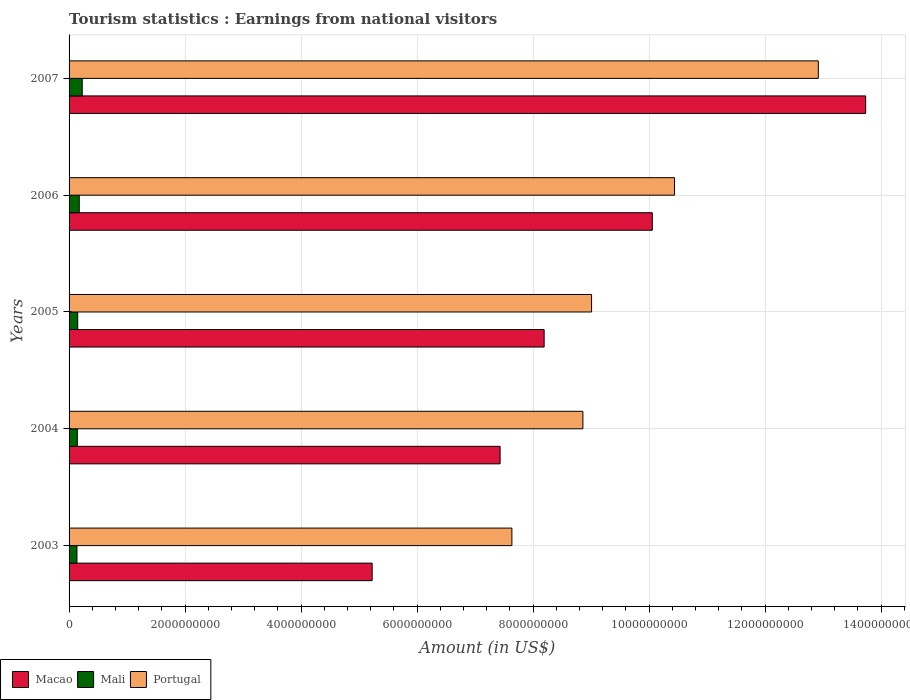Are the number of bars per tick equal to the number of legend labels?
Your answer should be compact. Yes. Are the number of bars on each tick of the Y-axis equal?
Give a very brief answer. Yes. How many bars are there on the 3rd tick from the bottom?
Give a very brief answer. 3. What is the label of the 3rd group of bars from the top?
Make the answer very short. 2005. In how many cases, is the number of bars for a given year not equal to the number of legend labels?
Make the answer very short. 0. What is the earnings from national visitors in Macao in 2003?
Give a very brief answer. 5.22e+09. Across all years, what is the maximum earnings from national visitors in Mali?
Your response must be concise. 2.27e+08. Across all years, what is the minimum earnings from national visitors in Mali?
Keep it short and to the point. 1.36e+08. What is the total earnings from national visitors in Portugal in the graph?
Offer a terse response. 4.89e+1. What is the difference between the earnings from national visitors in Macao in 2004 and that in 2007?
Offer a terse response. -6.30e+09. What is the difference between the earnings from national visitors in Mali in 2004 and the earnings from national visitors in Portugal in 2003?
Your answer should be compact. -7.49e+09. What is the average earnings from national visitors in Mali per year?
Offer a terse response. 1.66e+08. In the year 2004, what is the difference between the earnings from national visitors in Portugal and earnings from national visitors in Mali?
Ensure brevity in your answer.  8.72e+09. In how many years, is the earnings from national visitors in Portugal greater than 6000000000 US$?
Your response must be concise. 5. What is the ratio of the earnings from national visitors in Portugal in 2004 to that in 2005?
Make the answer very short. 0.98. What is the difference between the highest and the second highest earnings from national visitors in Mali?
Give a very brief answer. 5.16e+07. What is the difference between the highest and the lowest earnings from national visitors in Portugal?
Your answer should be compact. 5.28e+09. In how many years, is the earnings from national visitors in Portugal greater than the average earnings from national visitors in Portugal taken over all years?
Offer a terse response. 2. What does the 2nd bar from the top in 2004 represents?
Ensure brevity in your answer.  Mali. What does the 1st bar from the bottom in 2003 represents?
Make the answer very short. Macao. Is it the case that in every year, the sum of the earnings from national visitors in Macao and earnings from national visitors in Mali is greater than the earnings from national visitors in Portugal?
Provide a succinct answer. No. Are all the bars in the graph horizontal?
Your response must be concise. Yes. How many years are there in the graph?
Keep it short and to the point. 5. Are the values on the major ticks of X-axis written in scientific E-notation?
Offer a very short reply. No. Does the graph contain grids?
Offer a terse response. Yes. How many legend labels are there?
Keep it short and to the point. 3. How are the legend labels stacked?
Provide a succinct answer. Horizontal. What is the title of the graph?
Your answer should be compact. Tourism statistics : Earnings from national visitors. Does "Nicaragua" appear as one of the legend labels in the graph?
Offer a very short reply. No. What is the label or title of the Y-axis?
Ensure brevity in your answer.  Years. What is the Amount (in US$) of Macao in 2003?
Offer a terse response. 5.22e+09. What is the Amount (in US$) in Mali in 2003?
Provide a short and direct response. 1.36e+08. What is the Amount (in US$) of Portugal in 2003?
Offer a very short reply. 7.63e+09. What is the Amount (in US$) of Macao in 2004?
Offer a very short reply. 7.43e+09. What is the Amount (in US$) of Mali in 2004?
Give a very brief answer. 1.42e+08. What is the Amount (in US$) in Portugal in 2004?
Give a very brief answer. 8.86e+09. What is the Amount (in US$) of Macao in 2005?
Keep it short and to the point. 8.19e+09. What is the Amount (in US$) of Mali in 2005?
Your answer should be compact. 1.49e+08. What is the Amount (in US$) in Portugal in 2005?
Your response must be concise. 9.01e+09. What is the Amount (in US$) of Macao in 2006?
Your answer should be very brief. 1.01e+1. What is the Amount (in US$) in Mali in 2006?
Ensure brevity in your answer.  1.75e+08. What is the Amount (in US$) in Portugal in 2006?
Provide a succinct answer. 1.04e+1. What is the Amount (in US$) in Macao in 2007?
Give a very brief answer. 1.37e+1. What is the Amount (in US$) of Mali in 2007?
Offer a very short reply. 2.27e+08. What is the Amount (in US$) in Portugal in 2007?
Ensure brevity in your answer.  1.29e+1. Across all years, what is the maximum Amount (in US$) in Macao?
Offer a terse response. 1.37e+1. Across all years, what is the maximum Amount (in US$) in Mali?
Offer a very short reply. 2.27e+08. Across all years, what is the maximum Amount (in US$) of Portugal?
Provide a short and direct response. 1.29e+1. Across all years, what is the minimum Amount (in US$) of Macao?
Provide a short and direct response. 5.22e+09. Across all years, what is the minimum Amount (in US$) in Mali?
Your response must be concise. 1.36e+08. Across all years, what is the minimum Amount (in US$) of Portugal?
Give a very brief answer. 7.63e+09. What is the total Amount (in US$) of Macao in the graph?
Make the answer very short. 4.46e+1. What is the total Amount (in US$) in Mali in the graph?
Keep it short and to the point. 8.30e+08. What is the total Amount (in US$) of Portugal in the graph?
Keep it short and to the point. 4.89e+1. What is the difference between the Amount (in US$) of Macao in 2003 and that in 2004?
Your response must be concise. -2.21e+09. What is the difference between the Amount (in US$) in Mali in 2003 and that in 2004?
Your answer should be very brief. -6.30e+06. What is the difference between the Amount (in US$) in Portugal in 2003 and that in 2004?
Provide a short and direct response. -1.22e+09. What is the difference between the Amount (in US$) in Macao in 2003 and that in 2005?
Provide a succinct answer. -2.96e+09. What is the difference between the Amount (in US$) in Mali in 2003 and that in 2005?
Give a very brief answer. -1.32e+07. What is the difference between the Amount (in US$) in Portugal in 2003 and that in 2005?
Provide a short and direct response. -1.37e+09. What is the difference between the Amount (in US$) of Macao in 2003 and that in 2006?
Your answer should be very brief. -4.83e+09. What is the difference between the Amount (in US$) in Mali in 2003 and that in 2006?
Provide a short and direct response. -3.94e+07. What is the difference between the Amount (in US$) in Portugal in 2003 and that in 2006?
Your answer should be very brief. -2.80e+09. What is the difference between the Amount (in US$) in Macao in 2003 and that in 2007?
Offer a very short reply. -8.51e+09. What is the difference between the Amount (in US$) in Mali in 2003 and that in 2007?
Your response must be concise. -9.10e+07. What is the difference between the Amount (in US$) in Portugal in 2003 and that in 2007?
Provide a succinct answer. -5.28e+09. What is the difference between the Amount (in US$) of Macao in 2004 and that in 2005?
Make the answer very short. -7.59e+08. What is the difference between the Amount (in US$) of Mali in 2004 and that in 2005?
Keep it short and to the point. -6.90e+06. What is the difference between the Amount (in US$) in Portugal in 2004 and that in 2005?
Offer a very short reply. -1.50e+08. What is the difference between the Amount (in US$) of Macao in 2004 and that in 2006?
Provide a short and direct response. -2.62e+09. What is the difference between the Amount (in US$) in Mali in 2004 and that in 2006?
Give a very brief answer. -3.31e+07. What is the difference between the Amount (in US$) of Portugal in 2004 and that in 2006?
Offer a very short reply. -1.58e+09. What is the difference between the Amount (in US$) in Macao in 2004 and that in 2007?
Offer a very short reply. -6.30e+09. What is the difference between the Amount (in US$) in Mali in 2004 and that in 2007?
Your answer should be very brief. -8.47e+07. What is the difference between the Amount (in US$) in Portugal in 2004 and that in 2007?
Your answer should be compact. -4.06e+09. What is the difference between the Amount (in US$) in Macao in 2005 and that in 2006?
Your answer should be very brief. -1.86e+09. What is the difference between the Amount (in US$) in Mali in 2005 and that in 2006?
Your answer should be very brief. -2.62e+07. What is the difference between the Amount (in US$) in Portugal in 2005 and that in 2006?
Provide a succinct answer. -1.43e+09. What is the difference between the Amount (in US$) of Macao in 2005 and that in 2007?
Give a very brief answer. -5.54e+09. What is the difference between the Amount (in US$) in Mali in 2005 and that in 2007?
Offer a terse response. -7.78e+07. What is the difference between the Amount (in US$) of Portugal in 2005 and that in 2007?
Provide a succinct answer. -3.91e+09. What is the difference between the Amount (in US$) of Macao in 2006 and that in 2007?
Ensure brevity in your answer.  -3.68e+09. What is the difference between the Amount (in US$) in Mali in 2006 and that in 2007?
Keep it short and to the point. -5.16e+07. What is the difference between the Amount (in US$) in Portugal in 2006 and that in 2007?
Give a very brief answer. -2.48e+09. What is the difference between the Amount (in US$) in Macao in 2003 and the Amount (in US$) in Mali in 2004?
Offer a terse response. 5.08e+09. What is the difference between the Amount (in US$) in Macao in 2003 and the Amount (in US$) in Portugal in 2004?
Your response must be concise. -3.63e+09. What is the difference between the Amount (in US$) of Mali in 2003 and the Amount (in US$) of Portugal in 2004?
Make the answer very short. -8.72e+09. What is the difference between the Amount (in US$) in Macao in 2003 and the Amount (in US$) in Mali in 2005?
Provide a succinct answer. 5.08e+09. What is the difference between the Amount (in US$) in Macao in 2003 and the Amount (in US$) in Portugal in 2005?
Give a very brief answer. -3.78e+09. What is the difference between the Amount (in US$) in Mali in 2003 and the Amount (in US$) in Portugal in 2005?
Ensure brevity in your answer.  -8.87e+09. What is the difference between the Amount (in US$) of Macao in 2003 and the Amount (in US$) of Mali in 2006?
Provide a succinct answer. 5.05e+09. What is the difference between the Amount (in US$) of Macao in 2003 and the Amount (in US$) of Portugal in 2006?
Offer a very short reply. -5.21e+09. What is the difference between the Amount (in US$) in Mali in 2003 and the Amount (in US$) in Portugal in 2006?
Provide a succinct answer. -1.03e+1. What is the difference between the Amount (in US$) of Macao in 2003 and the Amount (in US$) of Mali in 2007?
Offer a terse response. 5.00e+09. What is the difference between the Amount (in US$) in Macao in 2003 and the Amount (in US$) in Portugal in 2007?
Make the answer very short. -7.69e+09. What is the difference between the Amount (in US$) in Mali in 2003 and the Amount (in US$) in Portugal in 2007?
Keep it short and to the point. -1.28e+1. What is the difference between the Amount (in US$) in Macao in 2004 and the Amount (in US$) in Mali in 2005?
Your response must be concise. 7.28e+09. What is the difference between the Amount (in US$) in Macao in 2004 and the Amount (in US$) in Portugal in 2005?
Provide a succinct answer. -1.58e+09. What is the difference between the Amount (in US$) of Mali in 2004 and the Amount (in US$) of Portugal in 2005?
Keep it short and to the point. -8.87e+09. What is the difference between the Amount (in US$) of Macao in 2004 and the Amount (in US$) of Mali in 2006?
Provide a short and direct response. 7.26e+09. What is the difference between the Amount (in US$) of Macao in 2004 and the Amount (in US$) of Portugal in 2006?
Keep it short and to the point. -3.01e+09. What is the difference between the Amount (in US$) of Mali in 2004 and the Amount (in US$) of Portugal in 2006?
Provide a short and direct response. -1.03e+1. What is the difference between the Amount (in US$) of Macao in 2004 and the Amount (in US$) of Mali in 2007?
Provide a succinct answer. 7.20e+09. What is the difference between the Amount (in US$) in Macao in 2004 and the Amount (in US$) in Portugal in 2007?
Your answer should be compact. -5.49e+09. What is the difference between the Amount (in US$) of Mali in 2004 and the Amount (in US$) of Portugal in 2007?
Keep it short and to the point. -1.28e+1. What is the difference between the Amount (in US$) in Macao in 2005 and the Amount (in US$) in Mali in 2006?
Your response must be concise. 8.01e+09. What is the difference between the Amount (in US$) of Macao in 2005 and the Amount (in US$) of Portugal in 2006?
Offer a very short reply. -2.25e+09. What is the difference between the Amount (in US$) of Mali in 2005 and the Amount (in US$) of Portugal in 2006?
Your answer should be compact. -1.03e+1. What is the difference between the Amount (in US$) in Macao in 2005 and the Amount (in US$) in Mali in 2007?
Provide a short and direct response. 7.96e+09. What is the difference between the Amount (in US$) in Macao in 2005 and the Amount (in US$) in Portugal in 2007?
Keep it short and to the point. -4.73e+09. What is the difference between the Amount (in US$) of Mali in 2005 and the Amount (in US$) of Portugal in 2007?
Your response must be concise. -1.28e+1. What is the difference between the Amount (in US$) of Macao in 2006 and the Amount (in US$) of Mali in 2007?
Keep it short and to the point. 9.83e+09. What is the difference between the Amount (in US$) of Macao in 2006 and the Amount (in US$) of Portugal in 2007?
Keep it short and to the point. -2.86e+09. What is the difference between the Amount (in US$) in Mali in 2006 and the Amount (in US$) in Portugal in 2007?
Keep it short and to the point. -1.27e+1. What is the average Amount (in US$) of Macao per year?
Your response must be concise. 8.93e+09. What is the average Amount (in US$) of Mali per year?
Provide a short and direct response. 1.66e+08. What is the average Amount (in US$) of Portugal per year?
Make the answer very short. 9.77e+09. In the year 2003, what is the difference between the Amount (in US$) of Macao and Amount (in US$) of Mali?
Provide a short and direct response. 5.09e+09. In the year 2003, what is the difference between the Amount (in US$) in Macao and Amount (in US$) in Portugal?
Make the answer very short. -2.41e+09. In the year 2003, what is the difference between the Amount (in US$) in Mali and Amount (in US$) in Portugal?
Give a very brief answer. -7.50e+09. In the year 2004, what is the difference between the Amount (in US$) of Macao and Amount (in US$) of Mali?
Your response must be concise. 7.29e+09. In the year 2004, what is the difference between the Amount (in US$) in Macao and Amount (in US$) in Portugal?
Offer a very short reply. -1.43e+09. In the year 2004, what is the difference between the Amount (in US$) in Mali and Amount (in US$) in Portugal?
Your answer should be compact. -8.72e+09. In the year 2005, what is the difference between the Amount (in US$) in Macao and Amount (in US$) in Mali?
Your answer should be very brief. 8.04e+09. In the year 2005, what is the difference between the Amount (in US$) of Macao and Amount (in US$) of Portugal?
Ensure brevity in your answer.  -8.18e+08. In the year 2005, what is the difference between the Amount (in US$) in Mali and Amount (in US$) in Portugal?
Ensure brevity in your answer.  -8.86e+09. In the year 2006, what is the difference between the Amount (in US$) of Macao and Amount (in US$) of Mali?
Provide a succinct answer. 9.88e+09. In the year 2006, what is the difference between the Amount (in US$) in Macao and Amount (in US$) in Portugal?
Your answer should be very brief. -3.83e+08. In the year 2006, what is the difference between the Amount (in US$) in Mali and Amount (in US$) in Portugal?
Make the answer very short. -1.03e+1. In the year 2007, what is the difference between the Amount (in US$) in Macao and Amount (in US$) in Mali?
Keep it short and to the point. 1.35e+1. In the year 2007, what is the difference between the Amount (in US$) of Macao and Amount (in US$) of Portugal?
Your answer should be very brief. 8.16e+08. In the year 2007, what is the difference between the Amount (in US$) in Mali and Amount (in US$) in Portugal?
Keep it short and to the point. -1.27e+1. What is the ratio of the Amount (in US$) of Macao in 2003 to that in 2004?
Provide a succinct answer. 0.7. What is the ratio of the Amount (in US$) in Mali in 2003 to that in 2004?
Offer a very short reply. 0.96. What is the ratio of the Amount (in US$) in Portugal in 2003 to that in 2004?
Give a very brief answer. 0.86. What is the ratio of the Amount (in US$) in Macao in 2003 to that in 2005?
Make the answer very short. 0.64. What is the ratio of the Amount (in US$) of Mali in 2003 to that in 2005?
Your answer should be compact. 0.91. What is the ratio of the Amount (in US$) in Portugal in 2003 to that in 2005?
Your answer should be very brief. 0.85. What is the ratio of the Amount (in US$) in Macao in 2003 to that in 2006?
Make the answer very short. 0.52. What is the ratio of the Amount (in US$) of Mali in 2003 to that in 2006?
Make the answer very short. 0.78. What is the ratio of the Amount (in US$) in Portugal in 2003 to that in 2006?
Ensure brevity in your answer.  0.73. What is the ratio of the Amount (in US$) in Macao in 2003 to that in 2007?
Your answer should be compact. 0.38. What is the ratio of the Amount (in US$) in Mali in 2003 to that in 2007?
Offer a very short reply. 0.6. What is the ratio of the Amount (in US$) in Portugal in 2003 to that in 2007?
Your answer should be compact. 0.59. What is the ratio of the Amount (in US$) in Macao in 2004 to that in 2005?
Your answer should be compact. 0.91. What is the ratio of the Amount (in US$) in Mali in 2004 to that in 2005?
Provide a short and direct response. 0.95. What is the ratio of the Amount (in US$) in Portugal in 2004 to that in 2005?
Your answer should be very brief. 0.98. What is the ratio of the Amount (in US$) in Macao in 2004 to that in 2006?
Ensure brevity in your answer.  0.74. What is the ratio of the Amount (in US$) of Mali in 2004 to that in 2006?
Your response must be concise. 0.81. What is the ratio of the Amount (in US$) in Portugal in 2004 to that in 2006?
Your answer should be compact. 0.85. What is the ratio of the Amount (in US$) of Macao in 2004 to that in 2007?
Provide a succinct answer. 0.54. What is the ratio of the Amount (in US$) in Mali in 2004 to that in 2007?
Provide a short and direct response. 0.63. What is the ratio of the Amount (in US$) in Portugal in 2004 to that in 2007?
Ensure brevity in your answer.  0.69. What is the ratio of the Amount (in US$) of Macao in 2005 to that in 2006?
Make the answer very short. 0.81. What is the ratio of the Amount (in US$) of Mali in 2005 to that in 2006?
Make the answer very short. 0.85. What is the ratio of the Amount (in US$) in Portugal in 2005 to that in 2006?
Ensure brevity in your answer.  0.86. What is the ratio of the Amount (in US$) in Macao in 2005 to that in 2007?
Provide a short and direct response. 0.6. What is the ratio of the Amount (in US$) in Mali in 2005 to that in 2007?
Make the answer very short. 0.66. What is the ratio of the Amount (in US$) in Portugal in 2005 to that in 2007?
Offer a very short reply. 0.7. What is the ratio of the Amount (in US$) in Macao in 2006 to that in 2007?
Your answer should be very brief. 0.73. What is the ratio of the Amount (in US$) in Mali in 2006 to that in 2007?
Provide a succinct answer. 0.77. What is the ratio of the Amount (in US$) in Portugal in 2006 to that in 2007?
Your response must be concise. 0.81. What is the difference between the highest and the second highest Amount (in US$) in Macao?
Your response must be concise. 3.68e+09. What is the difference between the highest and the second highest Amount (in US$) in Mali?
Your answer should be compact. 5.16e+07. What is the difference between the highest and the second highest Amount (in US$) in Portugal?
Offer a terse response. 2.48e+09. What is the difference between the highest and the lowest Amount (in US$) of Macao?
Make the answer very short. 8.51e+09. What is the difference between the highest and the lowest Amount (in US$) in Mali?
Make the answer very short. 9.10e+07. What is the difference between the highest and the lowest Amount (in US$) of Portugal?
Give a very brief answer. 5.28e+09. 